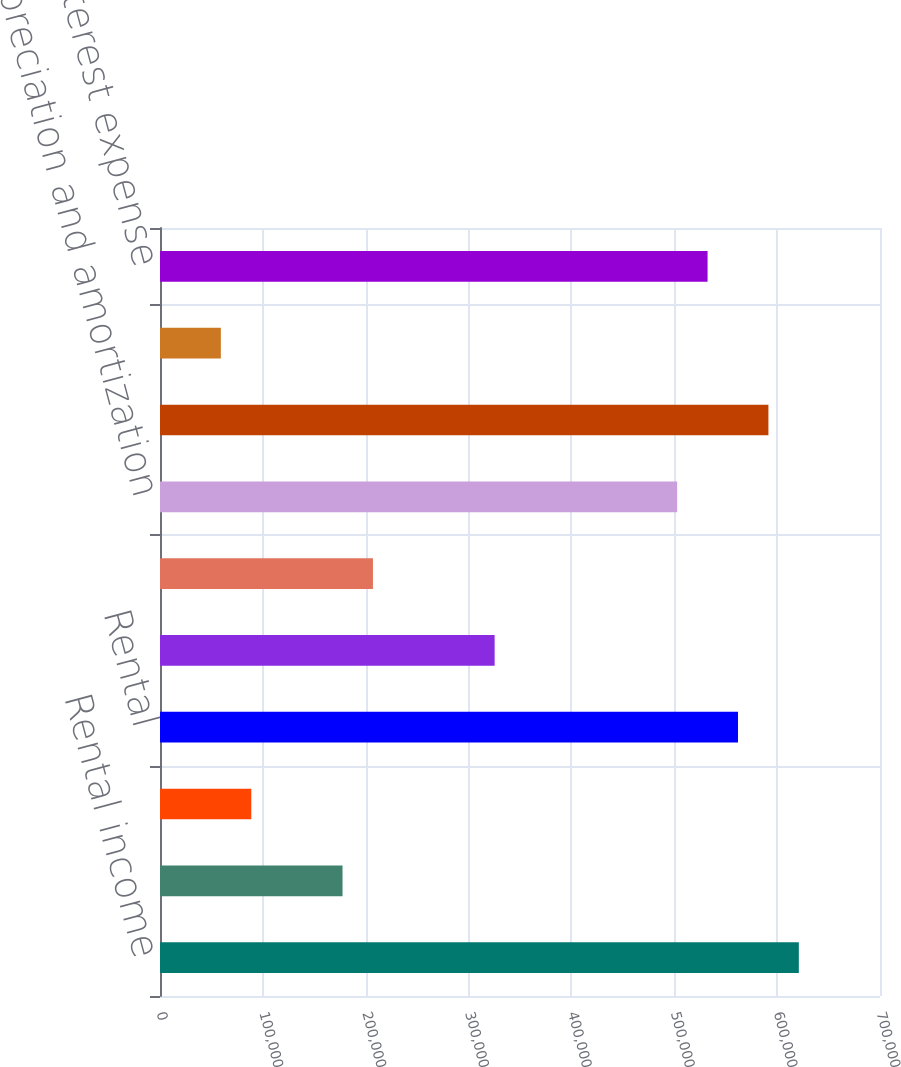Convert chart to OTSL. <chart><loc_0><loc_0><loc_500><loc_500><bar_chart><fcel>Rental income<fcel>Other property income<fcel>Mortgage interest income<fcel>Rental<fcel>Real estate taxes<fcel>General and administrative<fcel>Depreciation and amortization<fcel>Operating income<fcel>Other interest income<fcel>Interest expense<nl><fcel>621089<fcel>177454<fcel>88727.4<fcel>561938<fcel>325333<fcel>207030<fcel>502787<fcel>591514<fcel>59151.7<fcel>532362<nl></chart> 